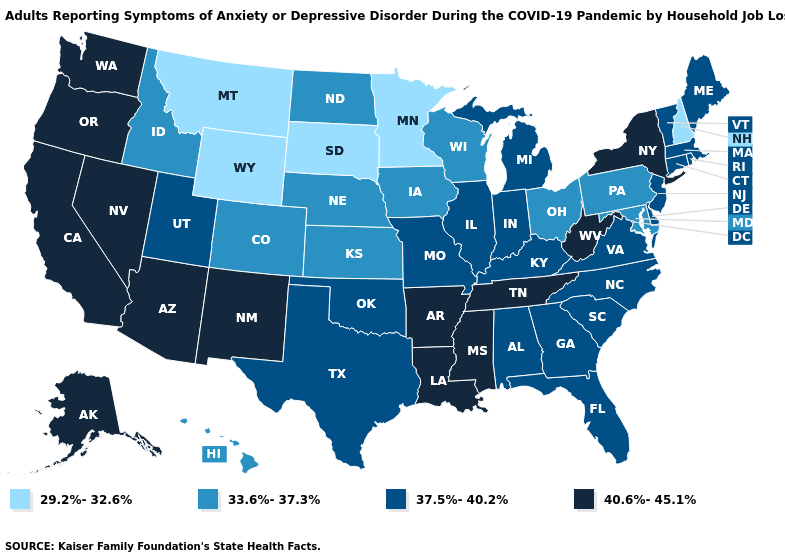Does Kansas have a lower value than Oklahoma?
Quick response, please. Yes. Does Alaska have the highest value in the USA?
Keep it brief. Yes. What is the highest value in the USA?
Be succinct. 40.6%-45.1%. Among the states that border West Virginia , which have the highest value?
Concise answer only. Kentucky, Virginia. What is the highest value in states that border Idaho?
Write a very short answer. 40.6%-45.1%. What is the highest value in the USA?
Be succinct. 40.6%-45.1%. Which states have the highest value in the USA?
Be succinct. Alaska, Arizona, Arkansas, California, Louisiana, Mississippi, Nevada, New Mexico, New York, Oregon, Tennessee, Washington, West Virginia. Among the states that border Massachusetts , which have the lowest value?
Concise answer only. New Hampshire. Name the states that have a value in the range 40.6%-45.1%?
Be succinct. Alaska, Arizona, Arkansas, California, Louisiana, Mississippi, Nevada, New Mexico, New York, Oregon, Tennessee, Washington, West Virginia. Among the states that border Rhode Island , which have the highest value?
Answer briefly. Connecticut, Massachusetts. Is the legend a continuous bar?
Give a very brief answer. No. What is the lowest value in states that border Idaho?
Concise answer only. 29.2%-32.6%. What is the value of Texas?
Give a very brief answer. 37.5%-40.2%. Among the states that border Nevada , does California have the lowest value?
Give a very brief answer. No. Does Michigan have the highest value in the MidWest?
Short answer required. Yes. 